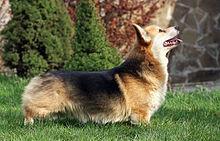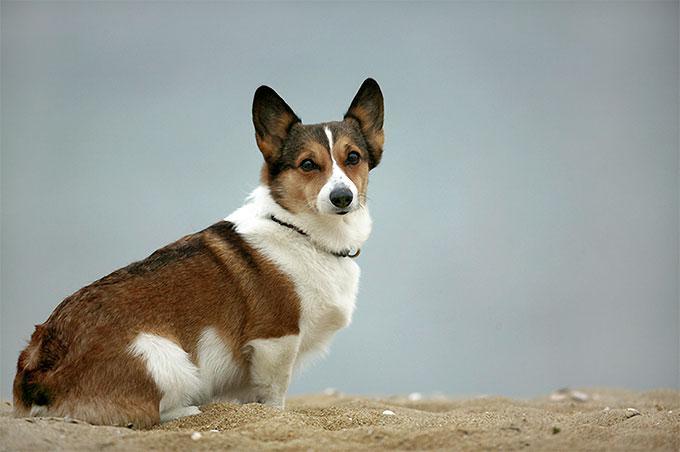The first image is the image on the left, the second image is the image on the right. Given the left and right images, does the statement "The image on the right has one dog with a collar exposed." hold true? Answer yes or no. Yes. The first image is the image on the left, the second image is the image on the right. Assess this claim about the two images: "In one of the image there is a dog standing in the grass.". Correct or not? Answer yes or no. Yes. 